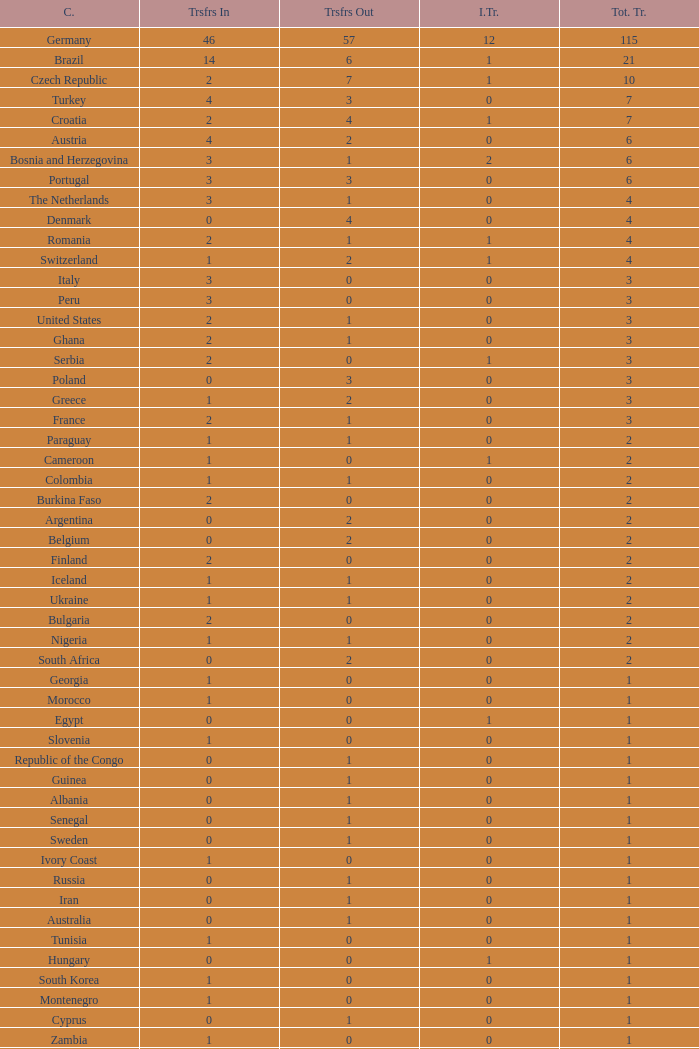What are the Transfers out for Peru? 0.0. Parse the table in full. {'header': ['C.', 'Trsfrs In', 'Trsfrs Out', 'I.Tr.', 'Tot. Tr.'], 'rows': [['Germany', '46', '57', '12', '115'], ['Brazil', '14', '6', '1', '21'], ['Czech Republic', '2', '7', '1', '10'], ['Turkey', '4', '3', '0', '7'], ['Croatia', '2', '4', '1', '7'], ['Austria', '4', '2', '0', '6'], ['Bosnia and Herzegovina', '3', '1', '2', '6'], ['Portugal', '3', '3', '0', '6'], ['The Netherlands', '3', '1', '0', '4'], ['Denmark', '0', '4', '0', '4'], ['Romania', '2', '1', '1', '4'], ['Switzerland', '1', '2', '1', '4'], ['Italy', '3', '0', '0', '3'], ['Peru', '3', '0', '0', '3'], ['United States', '2', '1', '0', '3'], ['Ghana', '2', '1', '0', '3'], ['Serbia', '2', '0', '1', '3'], ['Poland', '0', '3', '0', '3'], ['Greece', '1', '2', '0', '3'], ['France', '2', '1', '0', '3'], ['Paraguay', '1', '1', '0', '2'], ['Cameroon', '1', '0', '1', '2'], ['Colombia', '1', '1', '0', '2'], ['Burkina Faso', '2', '0', '0', '2'], ['Argentina', '0', '2', '0', '2'], ['Belgium', '0', '2', '0', '2'], ['Finland', '2', '0', '0', '2'], ['Iceland', '1', '1', '0', '2'], ['Ukraine', '1', '1', '0', '2'], ['Bulgaria', '2', '0', '0', '2'], ['Nigeria', '1', '1', '0', '2'], ['South Africa', '0', '2', '0', '2'], ['Georgia', '1', '0', '0', '1'], ['Morocco', '1', '0', '0', '1'], ['Egypt', '0', '0', '1', '1'], ['Slovenia', '1', '0', '0', '1'], ['Republic of the Congo', '0', '1', '0', '1'], ['Guinea', '0', '1', '0', '1'], ['Albania', '0', '1', '0', '1'], ['Senegal', '0', '1', '0', '1'], ['Sweden', '0', '1', '0', '1'], ['Ivory Coast', '1', '0', '0', '1'], ['Russia', '0', '1', '0', '1'], ['Iran', '0', '1', '0', '1'], ['Australia', '0', '1', '0', '1'], ['Tunisia', '1', '0', '0', '1'], ['Hungary', '0', '0', '1', '1'], ['South Korea', '1', '0', '0', '1'], ['Montenegro', '1', '0', '0', '1'], ['Cyprus', '0', '1', '0', '1'], ['Zambia', '1', '0', '0', '1'], ['Israel', '1', '0', '0', '1'], ['Algeria', '1', '0', '0', '1'], ['Honduras', '0', '1', '0', '1'], ['Macedonia', '0', '1', '0', '1'], ['Last updated: September 2, 2008.', 'Last updated: September 2, 2008.', 'Last updated: September 2, 2008.', 'Last updated: September 2, 2008.', 'Last updated: September 2, 2008.']]} 